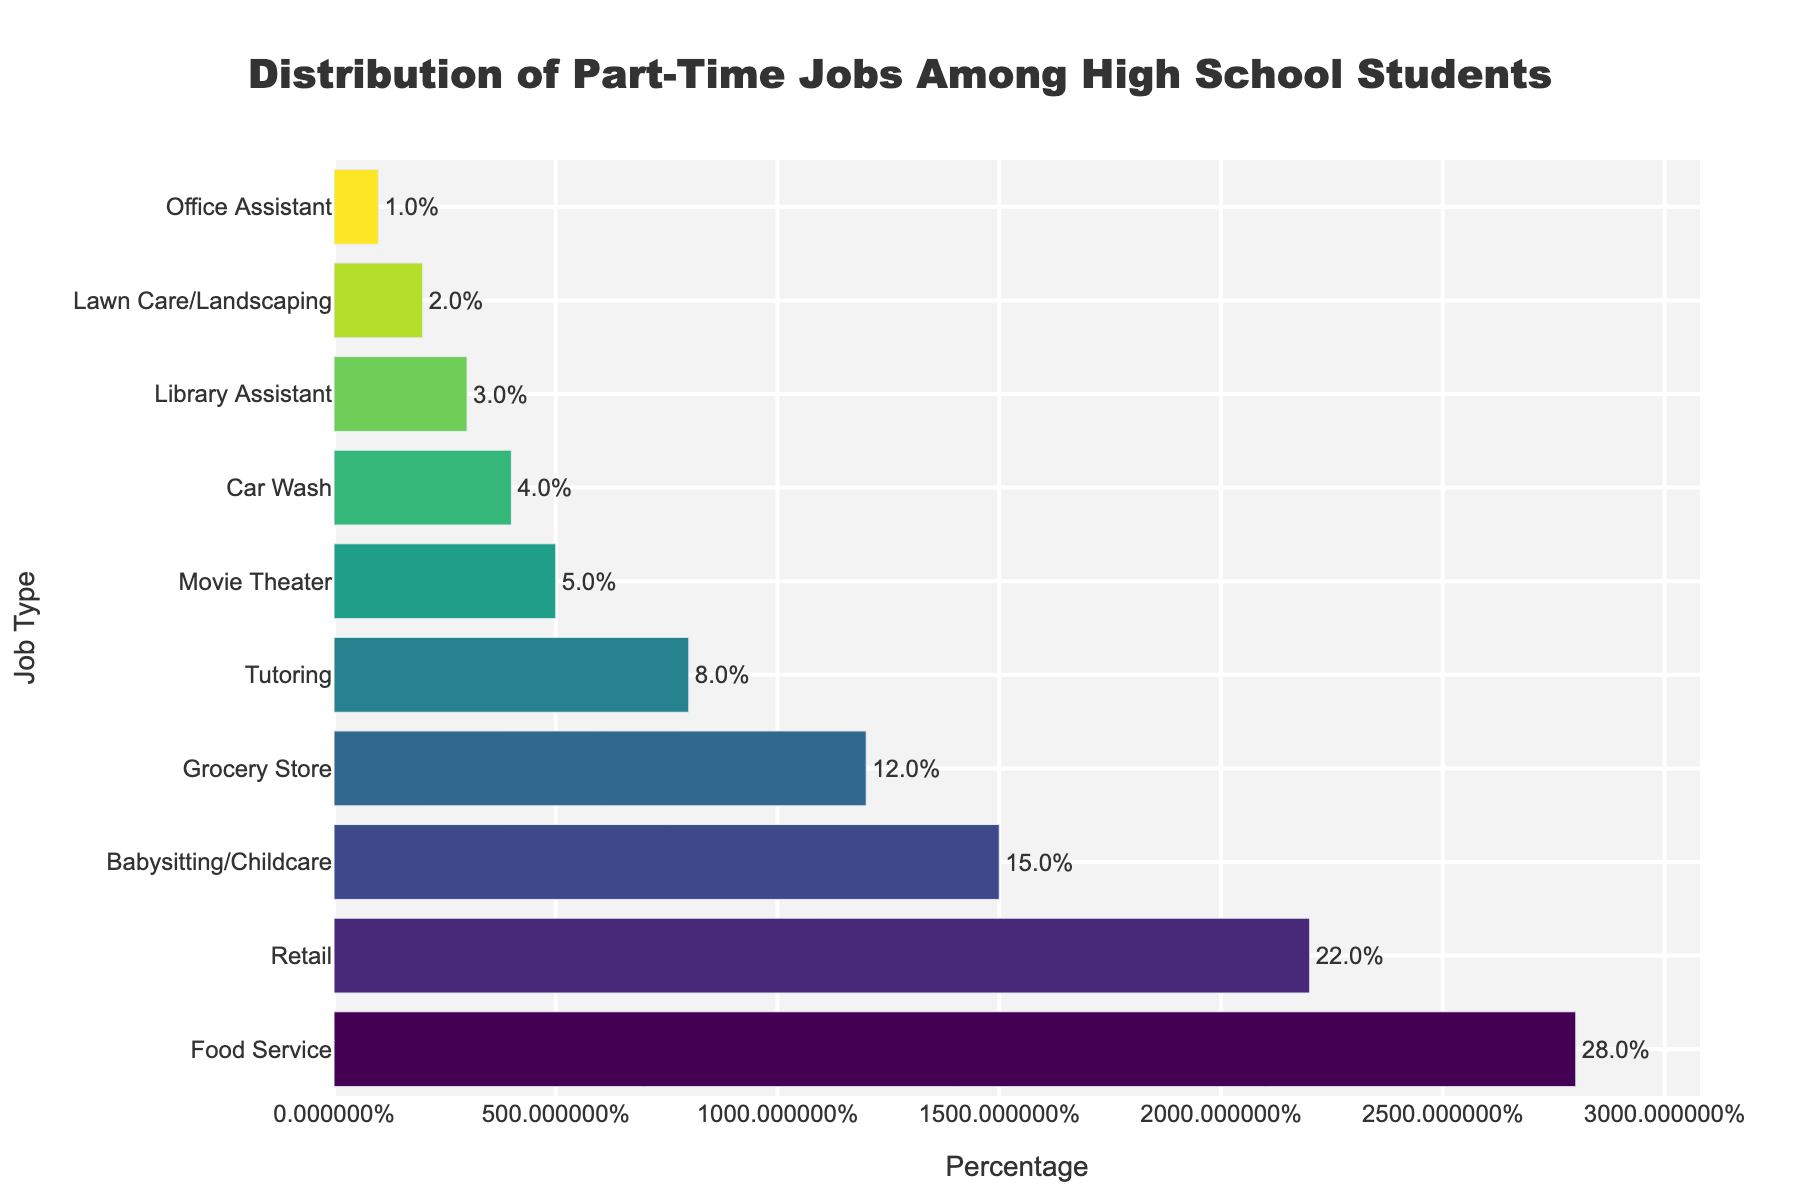What is the most common type of part-time job among high school students? The tallest bar in the chart corresponds to the 'Food Service' job type, which has the highest percentage of 28%. Thus, 'Food Service' is the most common type of part-time job among high school students.
Answer: Food Service Which two job types have a combined percentage of 37%? Summing up the percentages of 'Grocery Store' (12%) and 'Babysitting/Childcare' (15%) gives a total of 27%, but combining 'Babysitting/Childcare' (15%) and 'Tutoring' (8%) results in 23%. Similarly combining 'Car Wash' (4%) and 'Library Assistant' (3%) results in 7%. Finally, the sum of 'Retail' (22%) and 'Office Assistant' (1%) equals 23%. Therefore, the job types should be 'Food Service' (28%) and 'Car Wash' (4%), resulting in a total of 37%.
Answer: Food Service, Car Wash Which job type has a percentage twice that of the 'Car Wash'? The 'Car Wash' has a percentage of 4%. The job type with a percentage twice that of 4% is 8%, which corresponds to 'Tutoring'.
Answer: Tutoring What is the total percentage of part-time jobs related to 'Retail' and 'Grocery Store'? The 'Retail' job type has a 22% share, and the 'Grocery Store' has a 12% share. Adding them up, 22% + 12% equals 34%.
Answer: 34% What is the difference in percentage points between 'Retail' and 'Tutoring'? The percentage for 'Retail' is 22% and for 'Tutoring' is 8%. The difference is calculated as 22% - 8%, which equals 14 percentage points.
Answer: 14 percentage points Which job type represents the least popular option for part-time work among high school students? The shortest bar in the chart corresponds to the 'Office Assistant' job type, which has the lowest percentage of 1%. Thus, 'Office Assistant' is the least popular option.
Answer: Office Assistant How many job types have percentages higher than 10%? By examining the chart, the job types with percentages higher than 10% are 'Food Service' (28%), 'Retail' (22%), 'Babysitting/Childcare' (15%), and 'Grocery Store' (12%). Counting them gives 4 job types.
Answer: 4 Between 'Library Assistant' and 'Movie Theater', which job type has a lower percentage? The 'Library Assistant' job type has a percentage of 3%, while the 'Movie Theater' has a percentage of 5%. Comparing them, we see that 'Library Assistant' has the lower percentage.
Answer: Library Assistant 